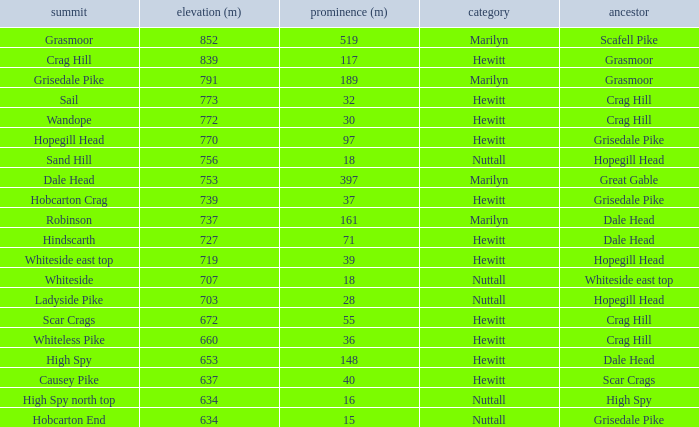Parse the full table. {'header': ['summit', 'elevation (m)', 'prominence (m)', 'category', 'ancestor'], 'rows': [['Grasmoor', '852', '519', 'Marilyn', 'Scafell Pike'], ['Crag Hill', '839', '117', 'Hewitt', 'Grasmoor'], ['Grisedale Pike', '791', '189', 'Marilyn', 'Grasmoor'], ['Sail', '773', '32', 'Hewitt', 'Crag Hill'], ['Wandope', '772', '30', 'Hewitt', 'Crag Hill'], ['Hopegill Head', '770', '97', 'Hewitt', 'Grisedale Pike'], ['Sand Hill', '756', '18', 'Nuttall', 'Hopegill Head'], ['Dale Head', '753', '397', 'Marilyn', 'Great Gable'], ['Hobcarton Crag', '739', '37', 'Hewitt', 'Grisedale Pike'], ['Robinson', '737', '161', 'Marilyn', 'Dale Head'], ['Hindscarth', '727', '71', 'Hewitt', 'Dale Head'], ['Whiteside east top', '719', '39', 'Hewitt', 'Hopegill Head'], ['Whiteside', '707', '18', 'Nuttall', 'Whiteside east top'], ['Ladyside Pike', '703', '28', 'Nuttall', 'Hopegill Head'], ['Scar Crags', '672', '55', 'Hewitt', 'Crag Hill'], ['Whiteless Pike', '660', '36', 'Hewitt', 'Crag Hill'], ['High Spy', '653', '148', 'Hewitt', 'Dale Head'], ['Causey Pike', '637', '40', 'Hewitt', 'Scar Crags'], ['High Spy north top', '634', '16', 'Nuttall', 'High Spy'], ['Hobcarton End', '634', '15', 'Nuttall', 'Grisedale Pike']]} What is the lowest height for Parent grasmoor when it has a Prom larger than 117? 791.0. 